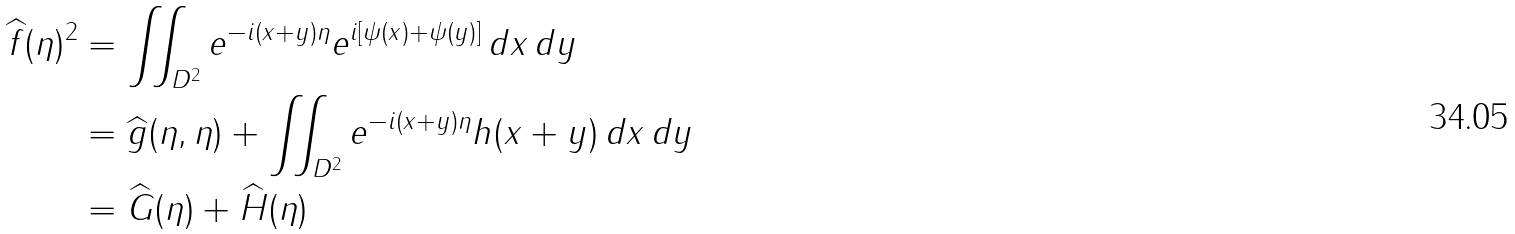<formula> <loc_0><loc_0><loc_500><loc_500>\widehat { f } ( \eta ) ^ { 2 } & = \iint _ { D ^ { 2 } } e ^ { - i ( x + y ) \eta } e ^ { i [ \psi ( x ) + \psi ( y ) ] } \, d x \, d y \\ & = \widehat { g } ( \eta , \eta ) + \iint _ { D ^ { 2 } } e ^ { - i ( x + y ) \eta } h ( x + y ) \, d x \, d y \\ & = \widehat { G } ( \eta ) + \widehat { H } ( \eta )</formula> 